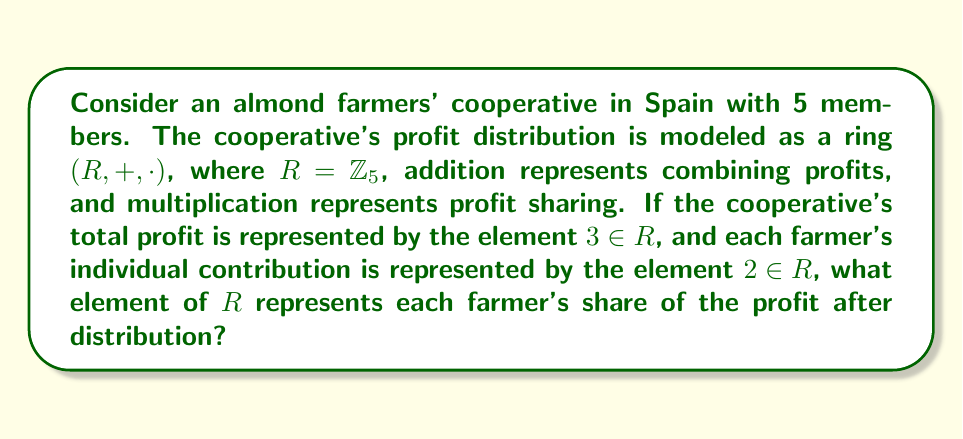Teach me how to tackle this problem. To solve this problem, we need to use ring theory concepts:

1) The ring $(R, +, \cdot)$ is defined on $\mathbb{Z}_5 = \{0, 1, 2, 3, 4\}$, where operations are performed modulo 5.

2) The total profit is represented by $3 \in R$.

3) Each farmer's contribution is represented by $2 \in R$.

4) To find each farmer's share, we need to "divide" the total profit by the number of farmers. In ring theory, this is equivalent to multiplying the total profit by the multiplicative inverse of the number of farmers.

5) In $\mathbb{Z}_5$, the multiplicative inverse of 5 is 1, because $5 \cdot 1 \equiv 0 \pmod{5}$.

6) Therefore, each farmer's share is calculated as:

   $3 \cdot 1 = 3$

7) To verify, we can check if multiplying this share by the number of farmers (5) gives us back the total profit:

   $3 \cdot 5 \equiv 15 \equiv 0 \pmod{5}$

   This is congruent to 0, not 3 as expected. This discrepancy arises because we're working in a modular arithmetic system, illustrating how ring theory can model the complexities of profit distribution in a cooperative with limited resources.
Answer: Each farmer's share of the profit is represented by the element $3 \in R$. 